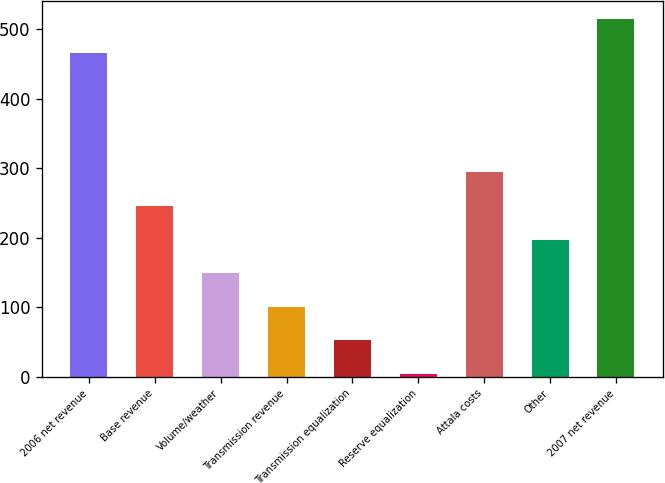Convert chart. <chart><loc_0><loc_0><loc_500><loc_500><bar_chart><fcel>2006 net revenue<fcel>Base revenue<fcel>Volume/weather<fcel>Transmission revenue<fcel>Transmission equalization<fcel>Reserve equalization<fcel>Attala costs<fcel>Other<fcel>2007 net revenue<nl><fcel>466.1<fcel>245.35<fcel>148.73<fcel>100.42<fcel>52.11<fcel>3.8<fcel>293.66<fcel>197.04<fcel>514.41<nl></chart> 